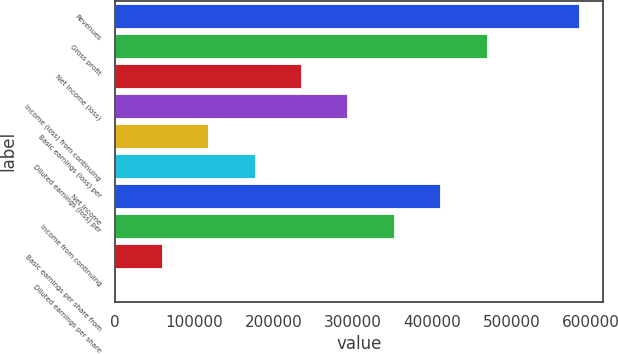Convert chart to OTSL. <chart><loc_0><loc_0><loc_500><loc_500><bar_chart><fcel>Revenues<fcel>Gross profit<fcel>Net income (loss)<fcel>Income (loss) from continuing<fcel>Basic earnings (loss) per<fcel>Diluted earnings (loss) per<fcel>Net income<fcel>Income from continuing<fcel>Basic earnings per share from<fcel>Diluted earnings per share<nl><fcel>585229<fcel>468183<fcel>234092<fcel>292615<fcel>117046<fcel>175569<fcel>409660<fcel>351137<fcel>58523.1<fcel>0.18<nl></chart> 